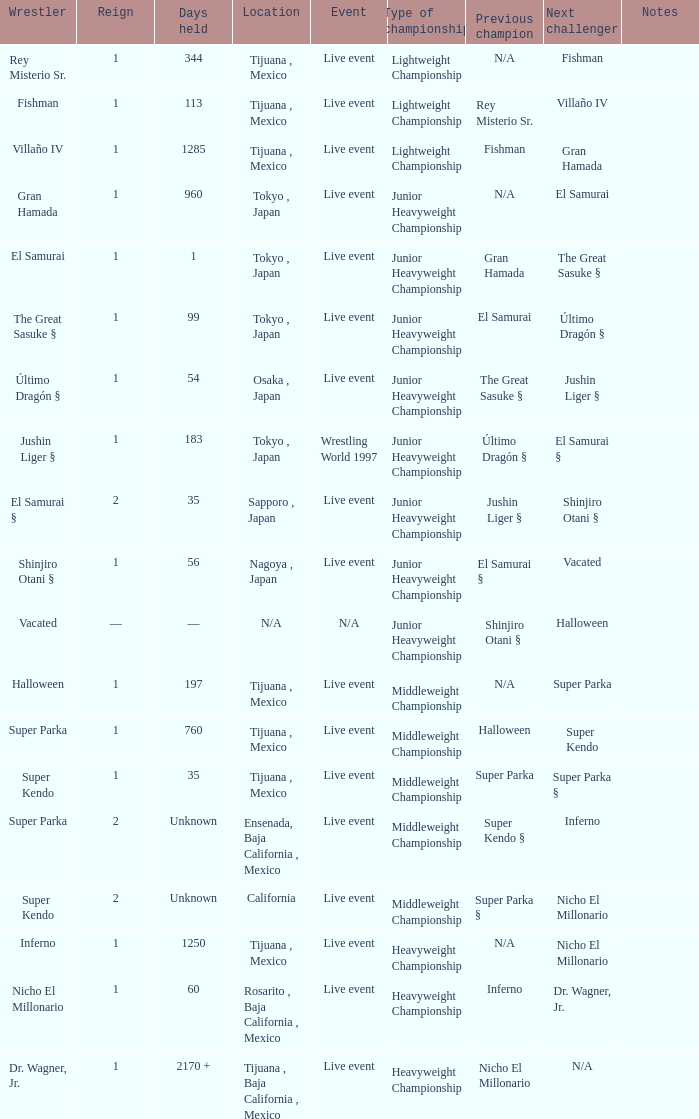What is the reign for super kendo who held it for 35 days? 1.0. 